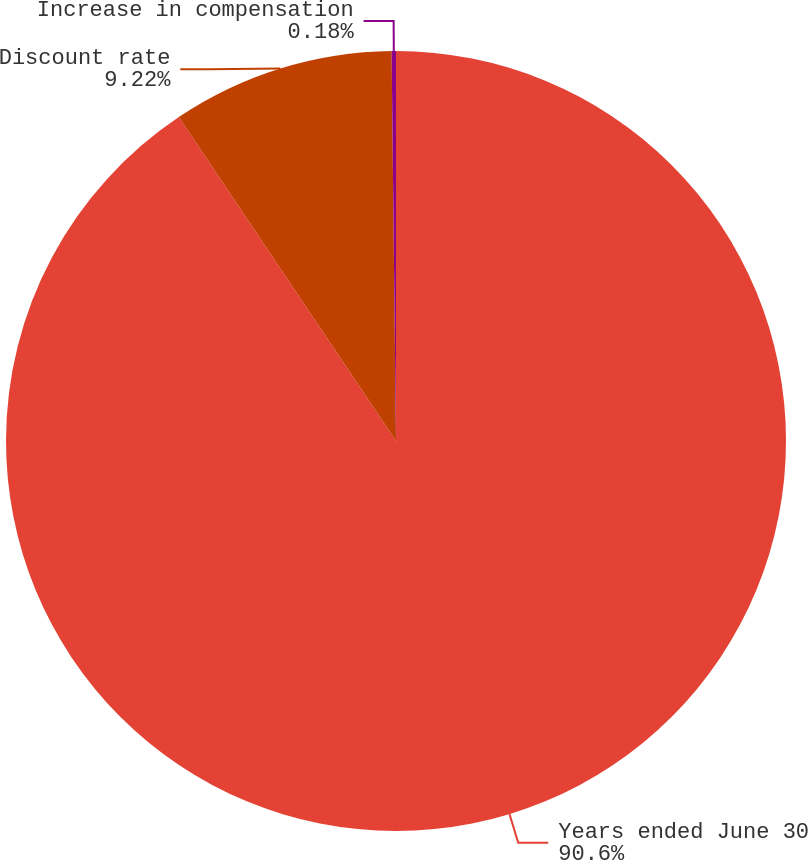<chart> <loc_0><loc_0><loc_500><loc_500><pie_chart><fcel>Years ended June 30<fcel>Discount rate<fcel>Increase in compensation<nl><fcel>90.6%<fcel>9.22%<fcel>0.18%<nl></chart> 